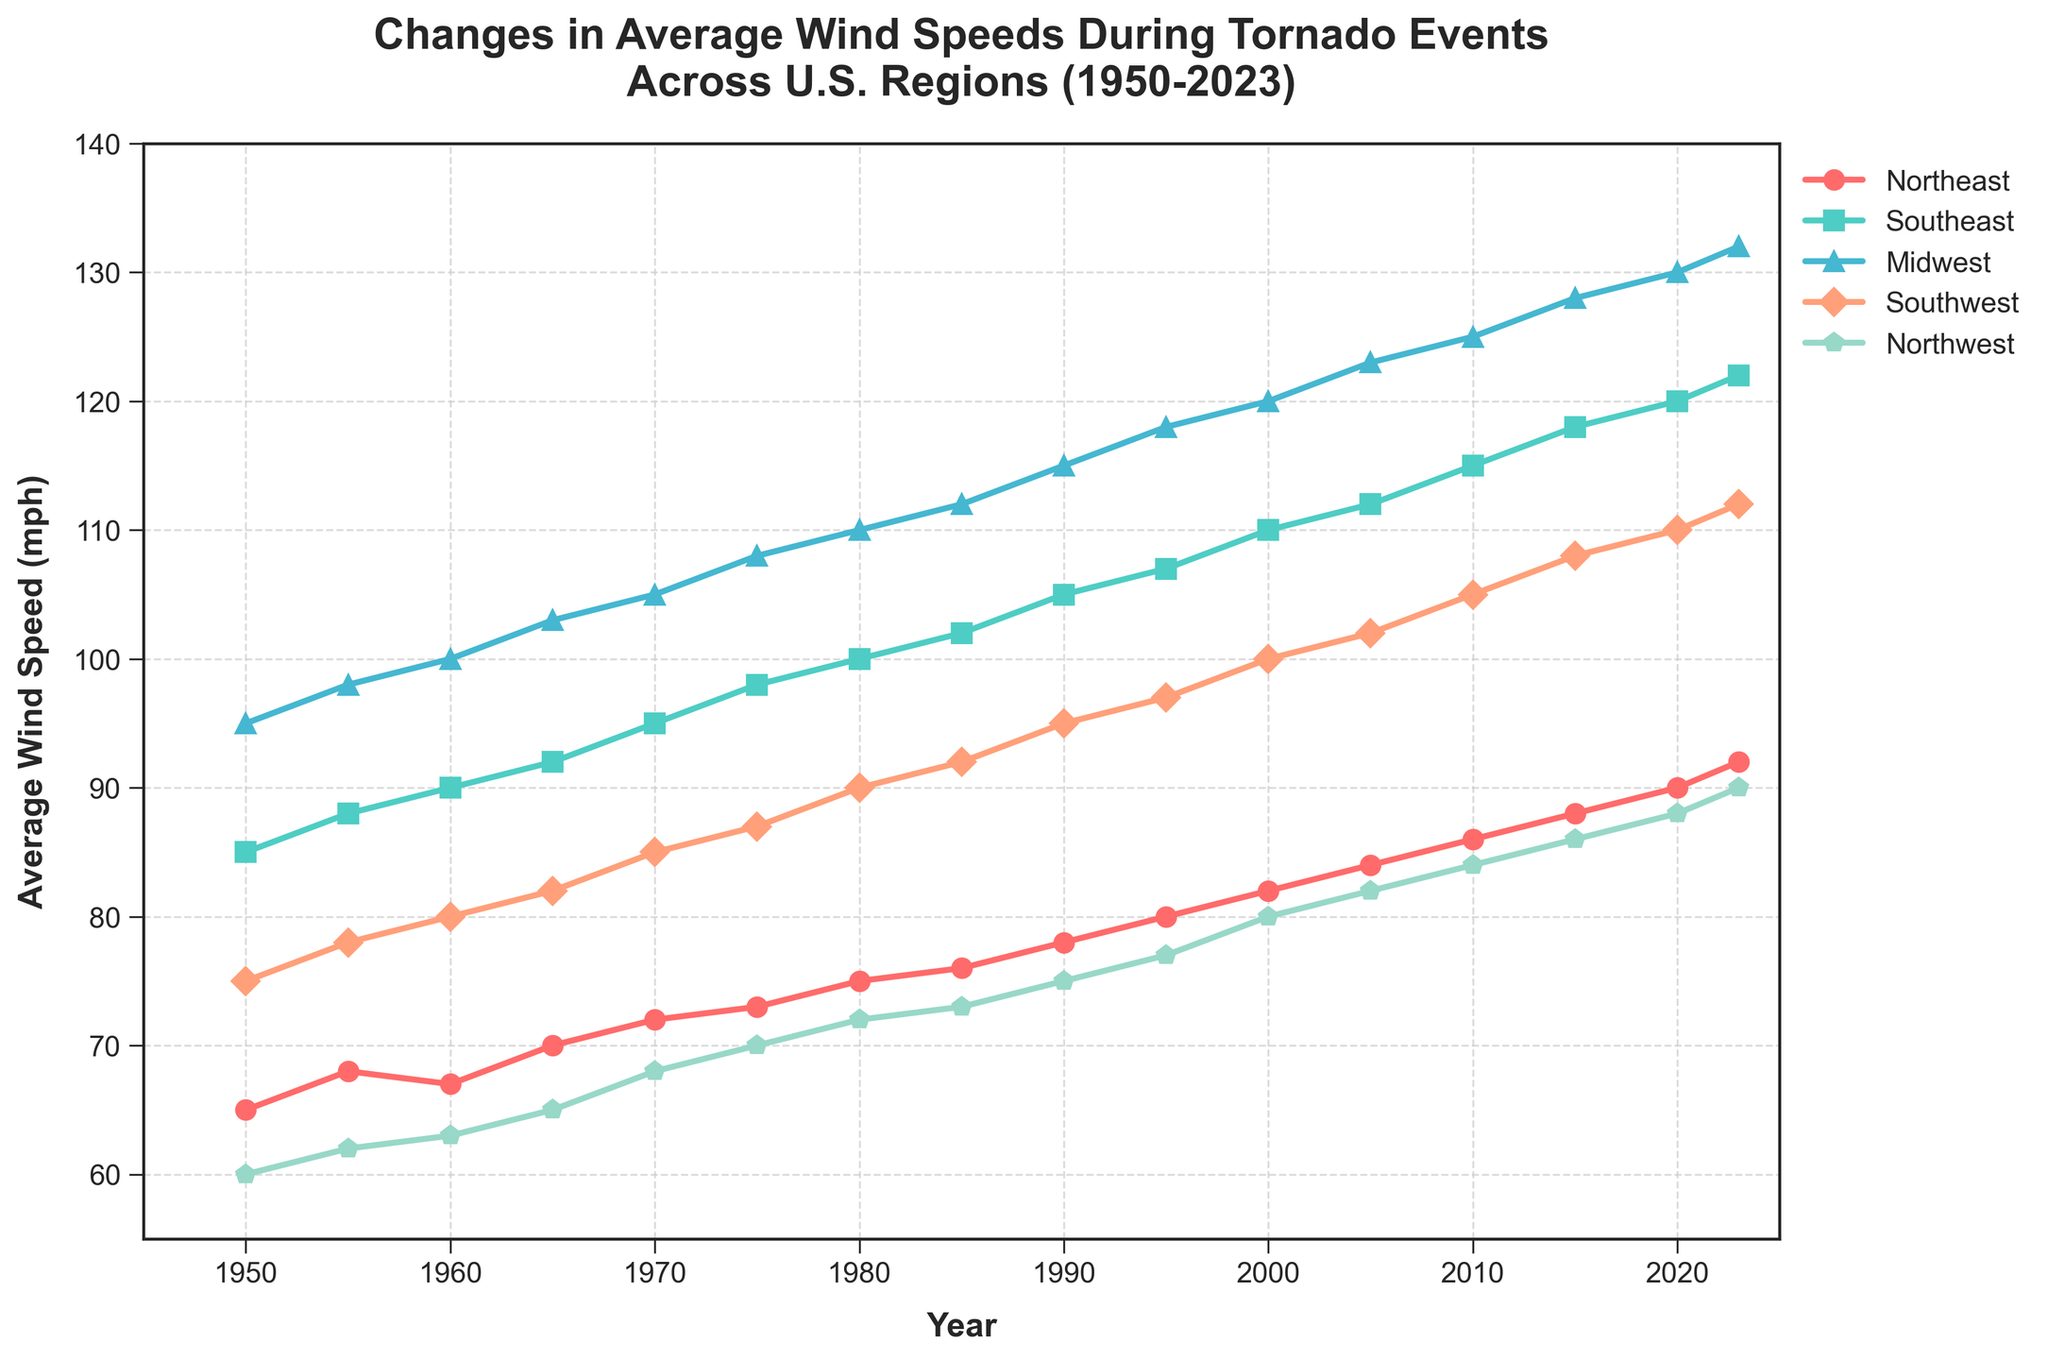What is the highest recorded average wind speed in the Midwest? Look at the line corresponding to the Midwest region and identify the peak value. The highest recorded value is near the end.
Answer: 132 mph Which region had the lowest average wind speed in 1980? Locate the year 1980 on the x-axis and compare the wind speeds for all regions. The Northeast has the lowest value.
Answer: Northeast How has the average wind speed in the Southeast changed from 1950 to 2023? Note the values for the Southeast in 1950 and 2023 from the y-axis. Calculate the difference: 122 - 85.
Answer: Increased by 37 mph Which region shows the most consistent increase in wind speed over the years? Examine the general trend for each line. The southeast shows a consistent upward trend without significant deviations.
Answer: Southeast Compare the average wind speeds of the Northwest and Southwest regions in 2020. Which was higher? Locate the year 2020 on the x-axis and compare the values for the Northwest and Southwest regions. The Southwest is higher.
Answer: Southwest What was the difference in wind speed between the Northeast and Midwest in 1975? Identify the wind speeds for both regions in 1975 and calculate the difference: 108 - 73.
Answer: 35 mph Identify the decade with the largest increase in wind speed for the Southeast region. Examine the increments between each decade for the Southeast. The increase from 1950 to 1960 is 90 - 85; from 1960 to 1970 it's 95 - 90; from 1970 to 1980 it's 100 - 95, etc. The largest increase is from 2010 to 2020.
Answer: 2010s What color represents the Midwest region on the graph? Look at the legend on the graph and find the color associated with the Midwest label.
Answer: Blue How many regions had an average wind speed above 100 mph in 2005? Locate the year 2005 and check the y-axis values for all regions. Count the regions above 100 mph.
Answer: Four regions What's the overall trend for average wind speeds in the Northwest from 1950 to 2023? Observe the line for the Northwest region from the start to the end. It shows a steady increase.
Answer: Increasing trend 